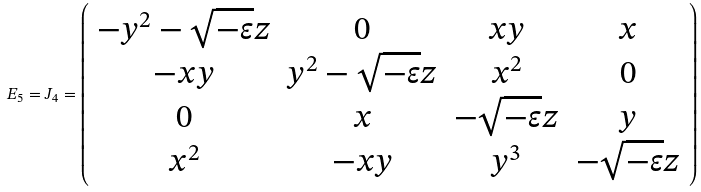Convert formula to latex. <formula><loc_0><loc_0><loc_500><loc_500>E _ { 5 } = J _ { 4 } = \left ( \begin{array} { c c c c } - y ^ { 2 } - \sqrt { - \varepsilon } z & 0 & x y & x \\ - x y & y ^ { 2 } - \sqrt { - \varepsilon } z & x ^ { 2 } & 0 \\ 0 & x & - \sqrt { - \varepsilon } z & y \\ x ^ { 2 } & - x y & y ^ { 3 } & - \sqrt { - \varepsilon } z \end{array} \right )</formula> 